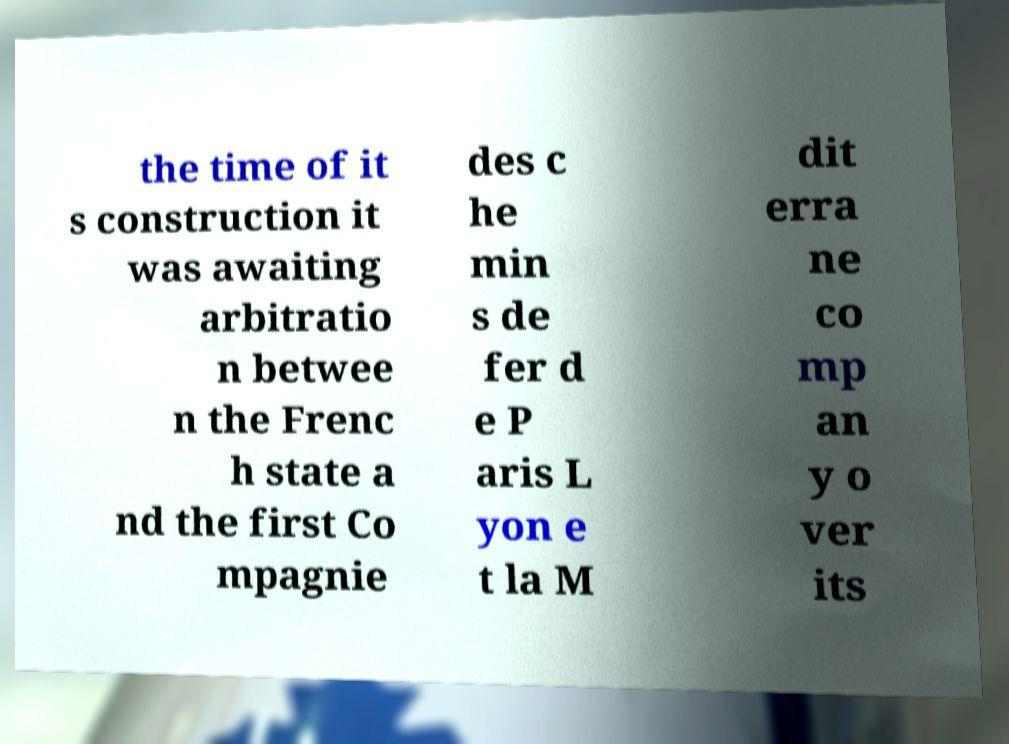For documentation purposes, I need the text within this image transcribed. Could you provide that? the time of it s construction it was awaiting arbitratio n betwee n the Frenc h state a nd the first Co mpagnie des c he min s de fer d e P aris L yon e t la M dit erra ne co mp an y o ver its 